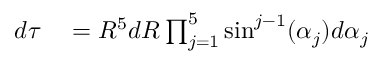Convert formula to latex. <formula><loc_0><loc_0><loc_500><loc_500>\begin{array} { r l } { d \tau } & = R ^ { 5 } d R \prod _ { j = 1 } ^ { 5 } \sin ^ { j - 1 } ( \alpha _ { j } ) d \alpha _ { j } } \end{array}</formula> 